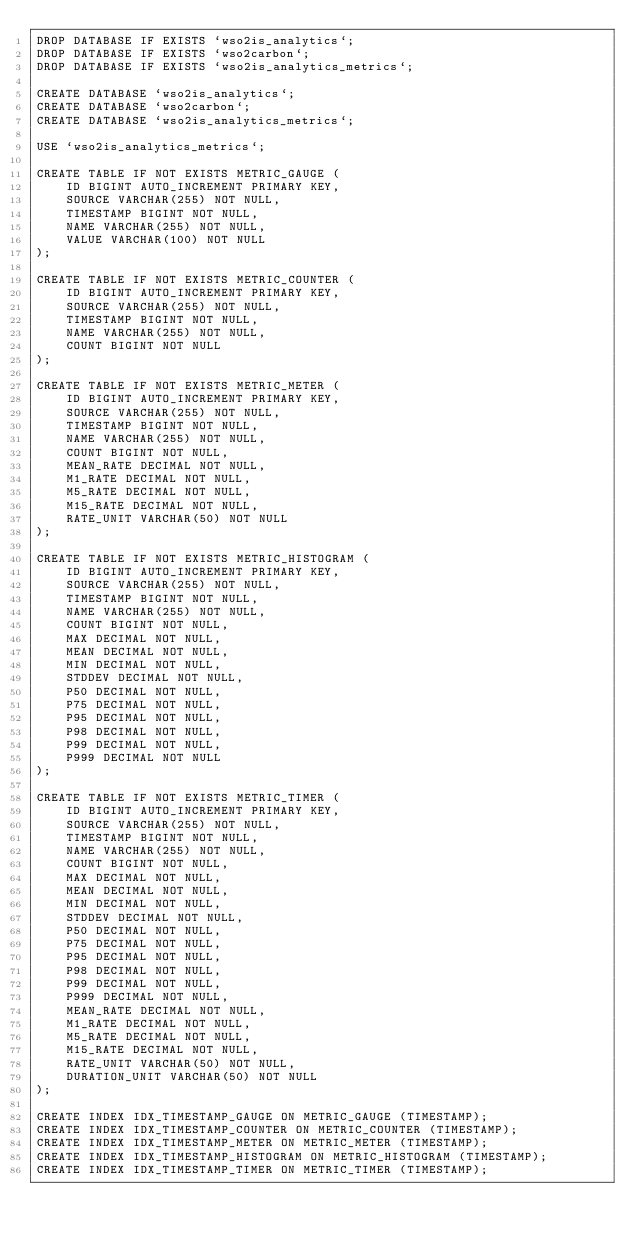<code> <loc_0><loc_0><loc_500><loc_500><_SQL_>DROP DATABASE IF EXISTS `wso2is_analytics`;
DROP DATABASE IF EXISTS `wso2carbon`;
DROP DATABASE IF EXISTS `wso2is_analytics_metrics`;

CREATE DATABASE `wso2is_analytics`;
CREATE DATABASE `wso2carbon`;
CREATE DATABASE `wso2is_analytics_metrics`;

USE `wso2is_analytics_metrics`;

CREATE TABLE IF NOT EXISTS METRIC_GAUGE (
    ID BIGINT AUTO_INCREMENT PRIMARY KEY,
    SOURCE VARCHAR(255) NOT NULL,
    TIMESTAMP BIGINT NOT NULL,
    NAME VARCHAR(255) NOT NULL,
    VALUE VARCHAR(100) NOT NULL
);

CREATE TABLE IF NOT EXISTS METRIC_COUNTER (
    ID BIGINT AUTO_INCREMENT PRIMARY KEY,
    SOURCE VARCHAR(255) NOT NULL,
    TIMESTAMP BIGINT NOT NULL,
    NAME VARCHAR(255) NOT NULL,
    COUNT BIGINT NOT NULL
);

CREATE TABLE IF NOT EXISTS METRIC_METER (
    ID BIGINT AUTO_INCREMENT PRIMARY KEY,
    SOURCE VARCHAR(255) NOT NULL,
    TIMESTAMP BIGINT NOT NULL,
    NAME VARCHAR(255) NOT NULL,
    COUNT BIGINT NOT NULL,
    MEAN_RATE DECIMAL NOT NULL,
    M1_RATE DECIMAL NOT NULL,
    M5_RATE DECIMAL NOT NULL,
    M15_RATE DECIMAL NOT NULL,
    RATE_UNIT VARCHAR(50) NOT NULL
);

CREATE TABLE IF NOT EXISTS METRIC_HISTOGRAM (
    ID BIGINT AUTO_INCREMENT PRIMARY KEY,
    SOURCE VARCHAR(255) NOT NULL,
    TIMESTAMP BIGINT NOT NULL,
    NAME VARCHAR(255) NOT NULL,
    COUNT BIGINT NOT NULL,
    MAX DECIMAL NOT NULL,
    MEAN DECIMAL NOT NULL,
    MIN DECIMAL NOT NULL,
    STDDEV DECIMAL NOT NULL,
    P50 DECIMAL NOT NULL,
    P75 DECIMAL NOT NULL,
    P95 DECIMAL NOT NULL,
    P98 DECIMAL NOT NULL,
    P99 DECIMAL NOT NULL,
    P999 DECIMAL NOT NULL
);

CREATE TABLE IF NOT EXISTS METRIC_TIMER (
    ID BIGINT AUTO_INCREMENT PRIMARY KEY,
    SOURCE VARCHAR(255) NOT NULL,
    TIMESTAMP BIGINT NOT NULL,
    NAME VARCHAR(255) NOT NULL,
    COUNT BIGINT NOT NULL,
    MAX DECIMAL NOT NULL,
    MEAN DECIMAL NOT NULL,
    MIN DECIMAL NOT NULL,
    STDDEV DECIMAL NOT NULL,
    P50 DECIMAL NOT NULL,
    P75 DECIMAL NOT NULL,
    P95 DECIMAL NOT NULL,
    P98 DECIMAL NOT NULL,
    P99 DECIMAL NOT NULL,
    P999 DECIMAL NOT NULL,
    MEAN_RATE DECIMAL NOT NULL,
    M1_RATE DECIMAL NOT NULL,
    M5_RATE DECIMAL NOT NULL,
    M15_RATE DECIMAL NOT NULL,
    RATE_UNIT VARCHAR(50) NOT NULL,
    DURATION_UNIT VARCHAR(50) NOT NULL
);

CREATE INDEX IDX_TIMESTAMP_GAUGE ON METRIC_GAUGE (TIMESTAMP);
CREATE INDEX IDX_TIMESTAMP_COUNTER ON METRIC_COUNTER (TIMESTAMP);
CREATE INDEX IDX_TIMESTAMP_METER ON METRIC_METER (TIMESTAMP);
CREATE INDEX IDX_TIMESTAMP_HISTOGRAM ON METRIC_HISTOGRAM (TIMESTAMP);
CREATE INDEX IDX_TIMESTAMP_TIMER ON METRIC_TIMER (TIMESTAMP);
</code> 